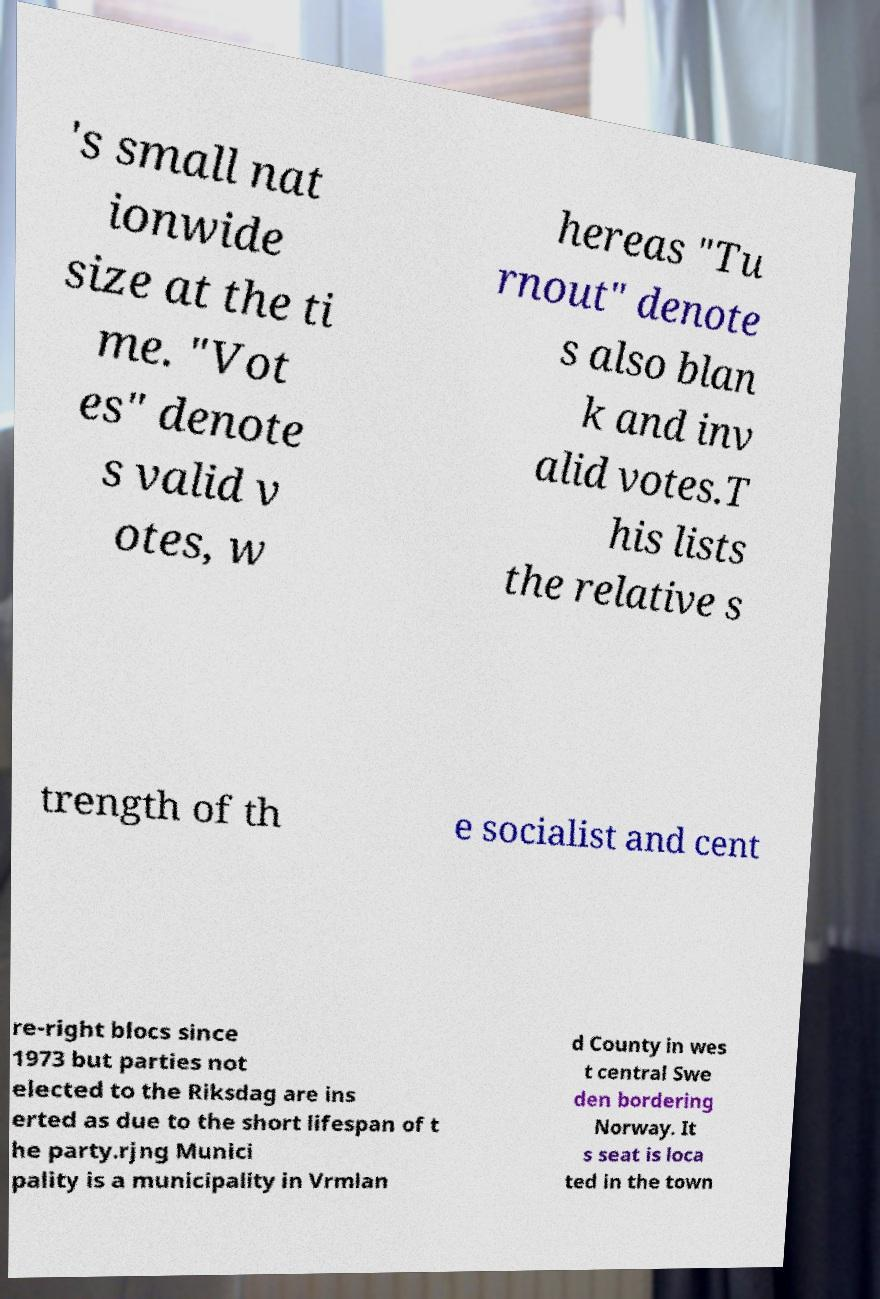Please read and relay the text visible in this image. What does it say? 's small nat ionwide size at the ti me. "Vot es" denote s valid v otes, w hereas "Tu rnout" denote s also blan k and inv alid votes.T his lists the relative s trength of th e socialist and cent re-right blocs since 1973 but parties not elected to the Riksdag are ins erted as due to the short lifespan of t he party.rjng Munici pality is a municipality in Vrmlan d County in wes t central Swe den bordering Norway. It s seat is loca ted in the town 